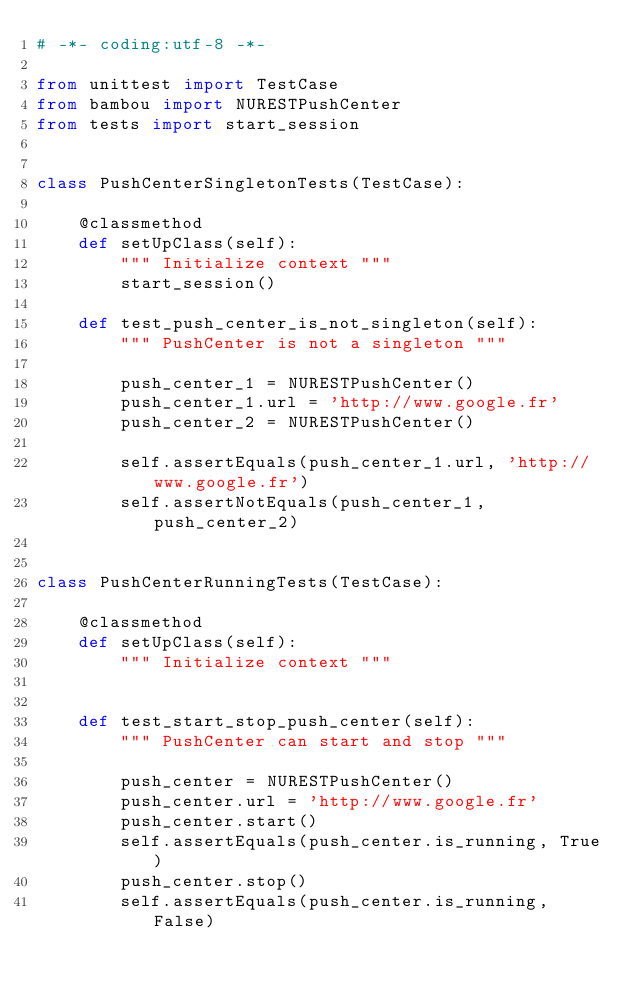Convert code to text. <code><loc_0><loc_0><loc_500><loc_500><_Python_># -*- coding:utf-8 -*-

from unittest import TestCase
from bambou import NURESTPushCenter
from tests import start_session


class PushCenterSingletonTests(TestCase):

    @classmethod
    def setUpClass(self):
        """ Initialize context """
        start_session()

    def test_push_center_is_not_singleton(self):
        """ PushCenter is not a singleton """

        push_center_1 = NURESTPushCenter()
        push_center_1.url = 'http://www.google.fr'
        push_center_2 = NURESTPushCenter()

        self.assertEquals(push_center_1.url, 'http://www.google.fr')
        self.assertNotEquals(push_center_1, push_center_2)


class PushCenterRunningTests(TestCase):

    @classmethod
    def setUpClass(self):
        """ Initialize context """


    def test_start_stop_push_center(self):
        """ PushCenter can start and stop """

        push_center = NURESTPushCenter()
        push_center.url = 'http://www.google.fr'
        push_center.start()
        self.assertEquals(push_center.is_running, True)
        push_center.stop()
        self.assertEquals(push_center.is_running, False)
</code> 